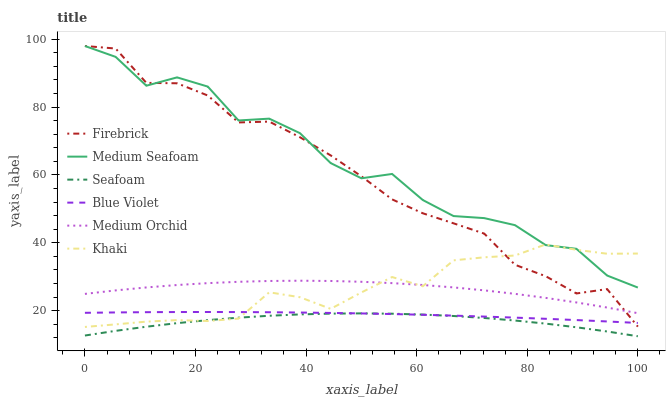Does Seafoam have the minimum area under the curve?
Answer yes or no. Yes. Does Medium Seafoam have the maximum area under the curve?
Answer yes or no. Yes. Does Firebrick have the minimum area under the curve?
Answer yes or no. No. Does Firebrick have the maximum area under the curve?
Answer yes or no. No. Is Blue Violet the smoothest?
Answer yes or no. Yes. Is Medium Seafoam the roughest?
Answer yes or no. Yes. Is Firebrick the smoothest?
Answer yes or no. No. Is Firebrick the roughest?
Answer yes or no. No. Does Seafoam have the lowest value?
Answer yes or no. Yes. Does Firebrick have the lowest value?
Answer yes or no. No. Does Medium Seafoam have the highest value?
Answer yes or no. Yes. Does Medium Orchid have the highest value?
Answer yes or no. No. Is Seafoam less than Firebrick?
Answer yes or no. Yes. Is Medium Orchid greater than Blue Violet?
Answer yes or no. Yes. Does Firebrick intersect Blue Violet?
Answer yes or no. Yes. Is Firebrick less than Blue Violet?
Answer yes or no. No. Is Firebrick greater than Blue Violet?
Answer yes or no. No. Does Seafoam intersect Firebrick?
Answer yes or no. No. 